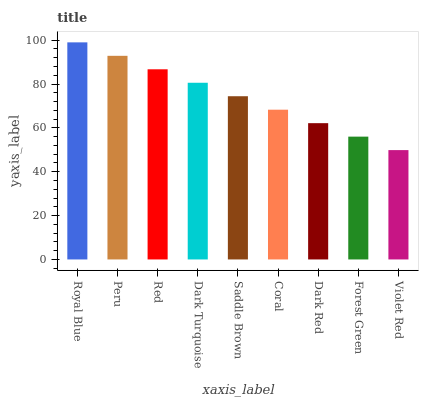Is Violet Red the minimum?
Answer yes or no. Yes. Is Royal Blue the maximum?
Answer yes or no. Yes. Is Peru the minimum?
Answer yes or no. No. Is Peru the maximum?
Answer yes or no. No. Is Royal Blue greater than Peru?
Answer yes or no. Yes. Is Peru less than Royal Blue?
Answer yes or no. Yes. Is Peru greater than Royal Blue?
Answer yes or no. No. Is Royal Blue less than Peru?
Answer yes or no. No. Is Saddle Brown the high median?
Answer yes or no. Yes. Is Saddle Brown the low median?
Answer yes or no. Yes. Is Peru the high median?
Answer yes or no. No. Is Red the low median?
Answer yes or no. No. 